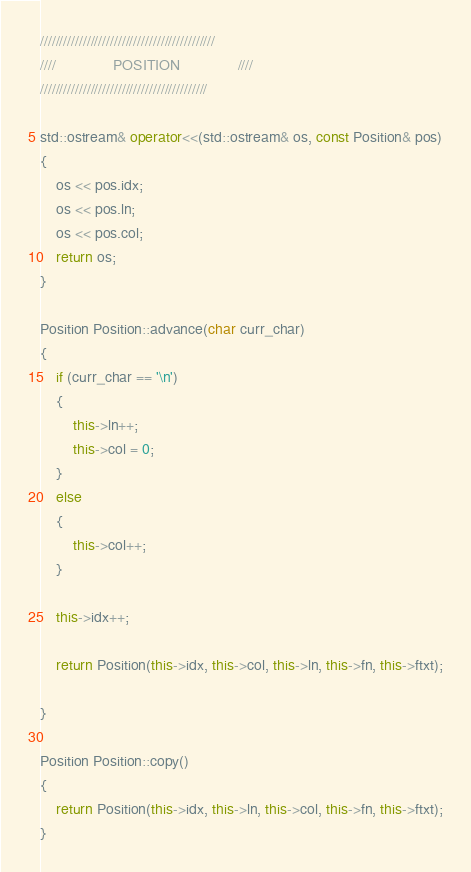Convert code to text. <code><loc_0><loc_0><loc_500><loc_500><_C++_>
/////////////////////////////////////////////
////              POSITION              ////
///////////////////////////////////////////

std::ostream& operator<<(std::ostream& os, const Position& pos)
{
	os << pos.idx;
	os << pos.ln;
	os << pos.col;
	return os;
}

Position Position::advance(char curr_char)
{
	if (curr_char == '\n')
	{
		this->ln++;
		this->col = 0;
	}
	else
	{
		this->col++;
	}

	this->idx++;

	return Position(this->idx, this->col, this->ln, this->fn, this->ftxt);

}

Position Position::copy()
{
	return Position(this->idx, this->ln, this->col, this->fn, this->ftxt);
}</code> 